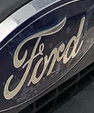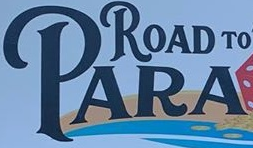What text appears in these images from left to right, separated by a semicolon? Ford; PARA 